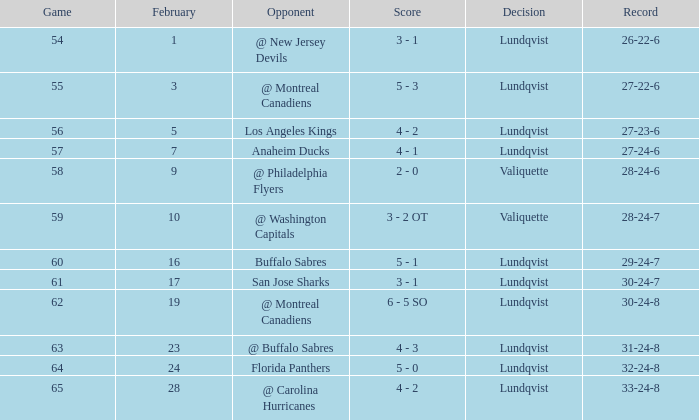What's the score for a game over 56 with a record of 29-24-7 with a lundqvist decision? 5 - 1. 